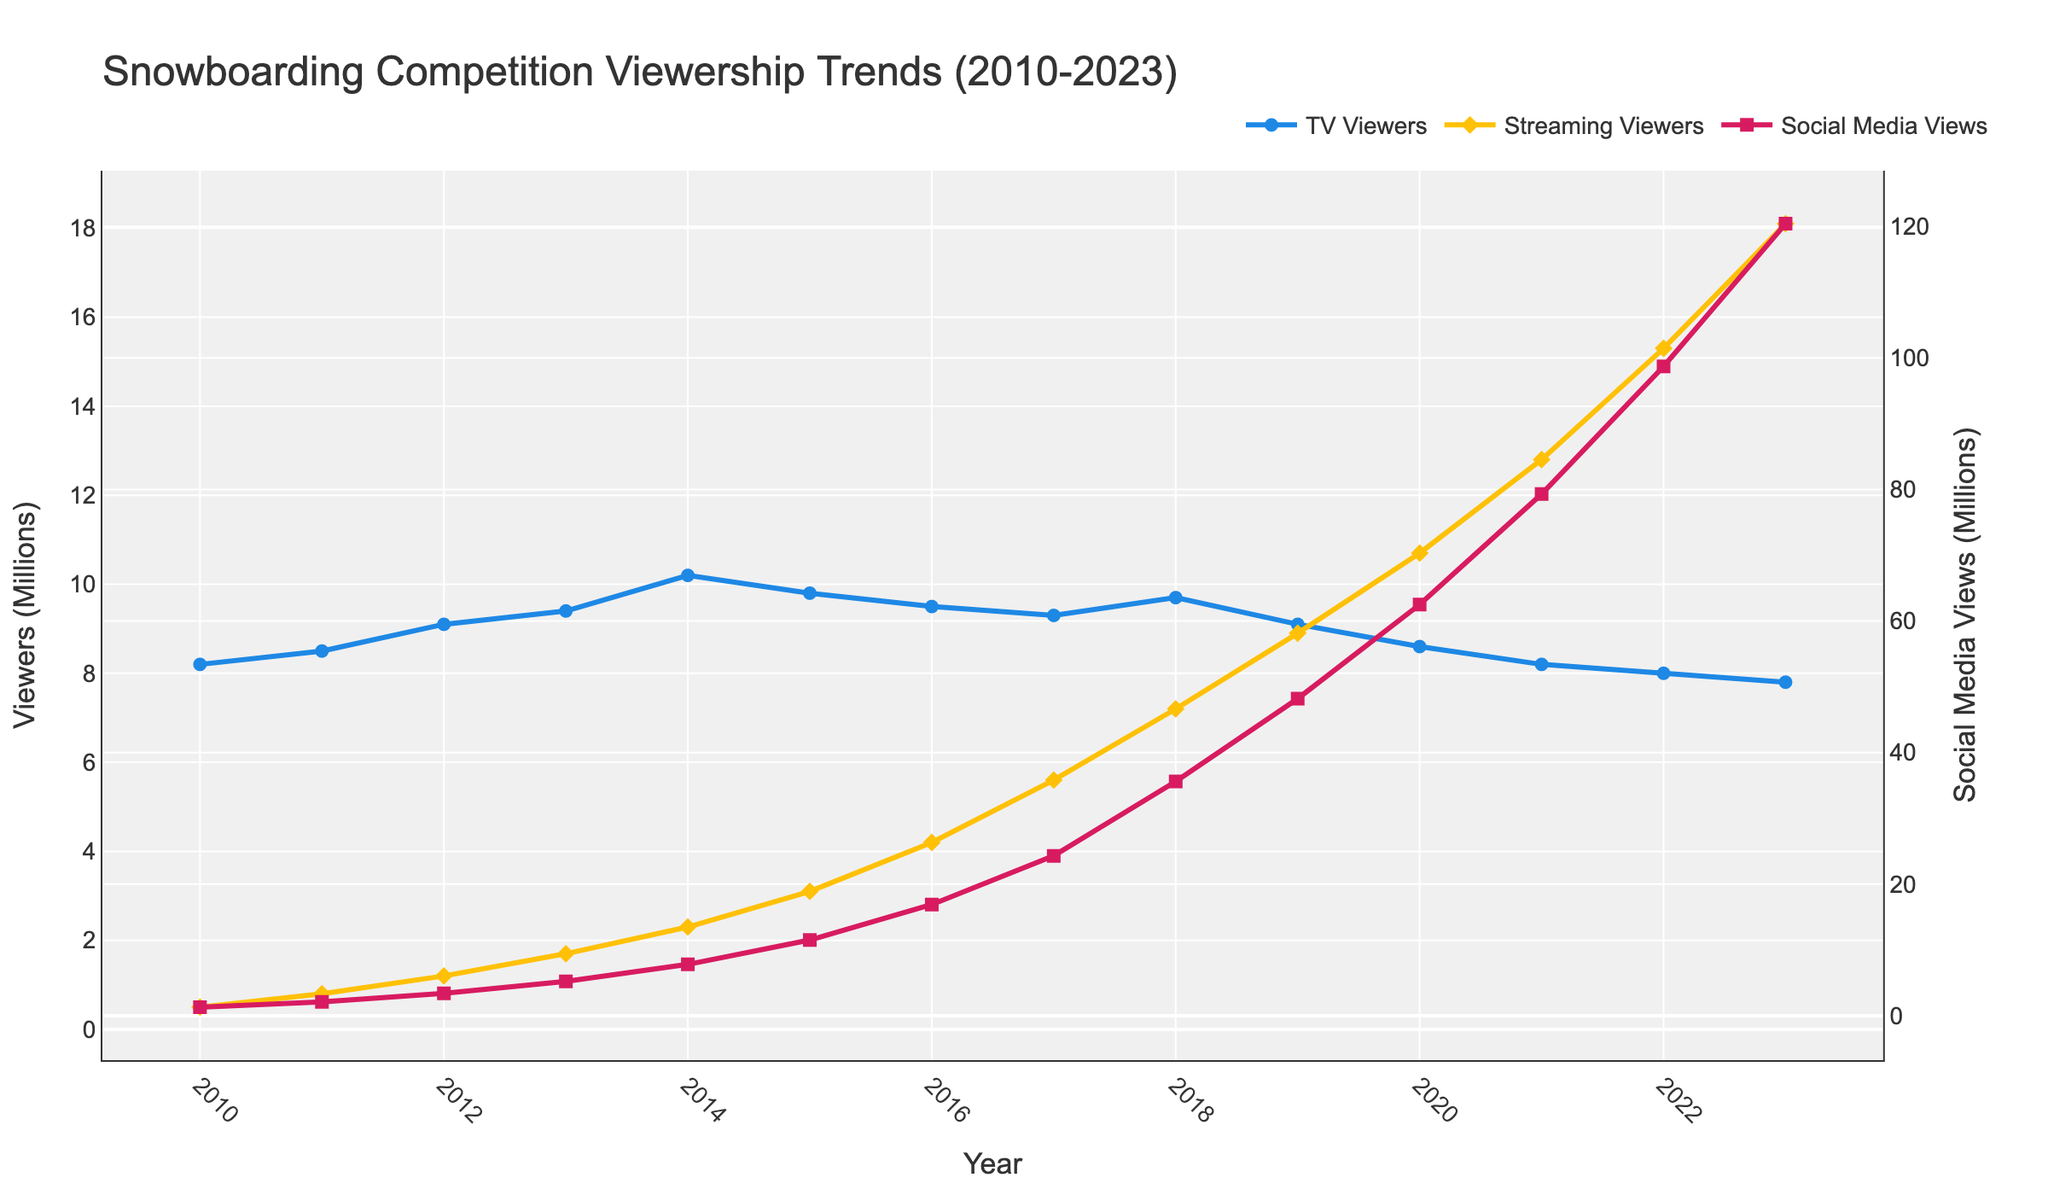What's the trend in TV viewership from 2010 to 2023? From the figure, you can see a slow decline in TV viewership. There was an initial increase from 8.2 million in 2010 to 10.2 million in 2014, followed by a consistent decline to 7.8 million by 2023.
Answer: A declining trend Which year had the highest number of social media views, and how many views were there? By looking at the pink line representing social media views, the highest point is in 2023 with 120.4 million views.
Answer: 2023 with 120.4 million views How do the TV viewers in 2017 compare to the streaming viewers in the same year? From the figure, TV viewers in 2017 are 9.3 million, while streaming viewers are 5.6 million. TV viewers are approximately 3.7 million more than streaming viewers in 2017.
Answer: TV viewers are 3.7 million more What is the average increase in streaming viewers from year to year? To find the average increase in streaming viewers, take the differences between each successive year and average them: 
(0.8-0.5) + (1.2-0.8) + (1.7-1.2) + (2.3-1.7) + (3.1-2.3) + (4.2-3.1) + (5.6-4.2) + (7.2-5.6) + (8.9-7.2) + (10.7-8.9) + (12.8-10.7) + (15.3-12.8) + (18.1-15.3) = 0.3 + 0.4 + 0.5 + 0.6 + 0.8 + 1.1 + 1.4 + 1.6 + 1.7 + 1.8 + 2.1 + 2.5 + 2.8 = 17.6
The average increase is 17.6 / 13 ≈ 1.35 million per year.
Answer: 1.35 million Between which two consecutive years did social media views experience the highest growth? Check the differences between each year for social media views. The biggest jump occurred between 2017 (24.3 million) and 2018 (35.6 million), with an increase of 11.3 million.
Answer: 2017 and 2018 Compare the trends of TV viewers and social media views over the years. What do you observe? TV viewership generally exhibits a declining trend after 2014, while social media views exhibit a consistent and rapid increase throughout the period. This shows a shift in viewer preference from traditional TV to social media platforms.
Answer: TV declining, Social Media increasing What was the difference in streaming viewers between 2010 and 2023? Streaming viewers increased from 0.5 million in 2010 to 18.1 million in 2023. The difference is 18.1 - 0.5 = 17.6 million.
Answer: 17.6 million 